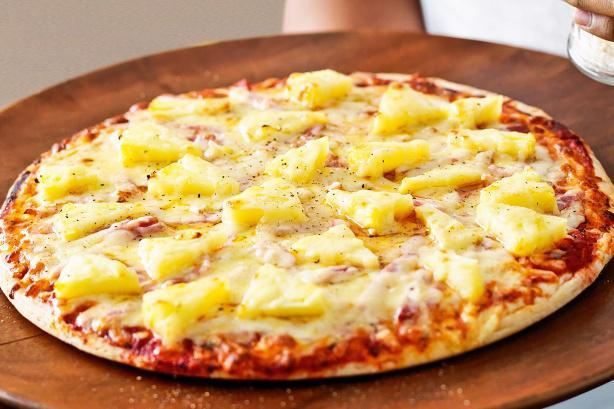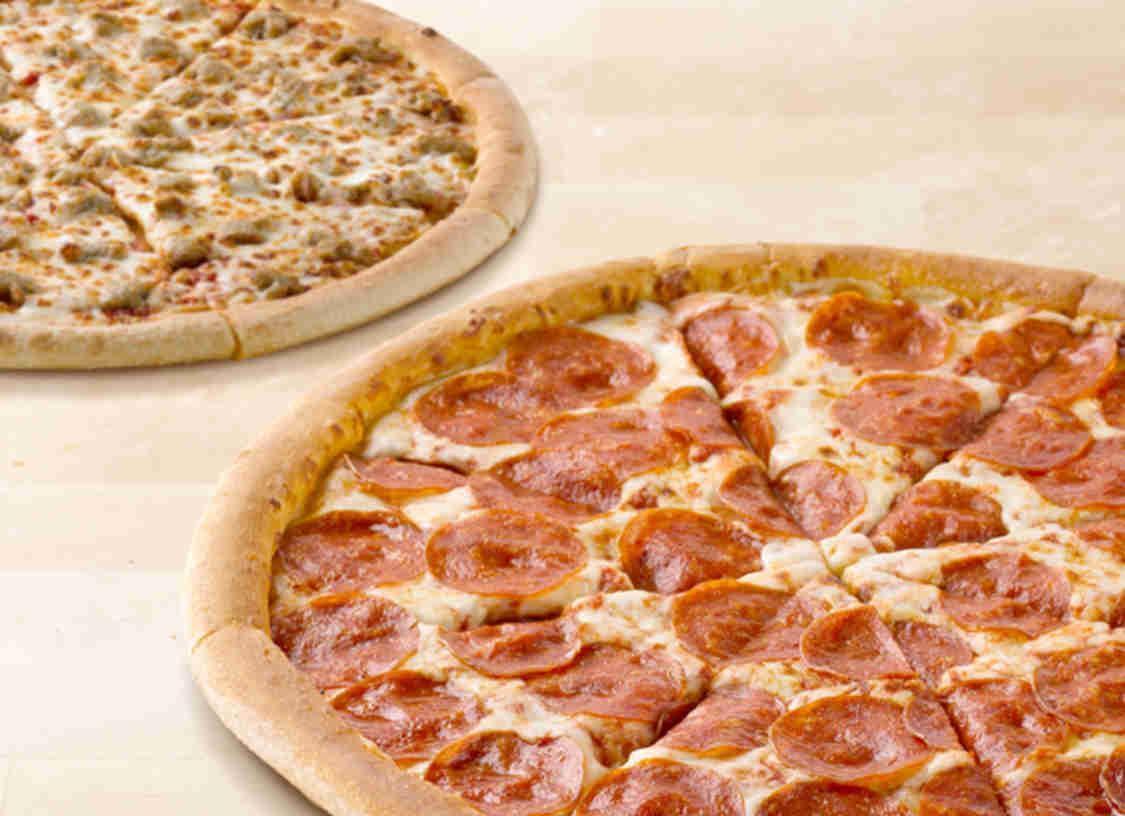The first image is the image on the left, the second image is the image on the right. For the images shown, is this caption "One image shows a pizza with pepperoni as a topping and the other image shows a pizza with no pepperoni." true? Answer yes or no. Yes. 